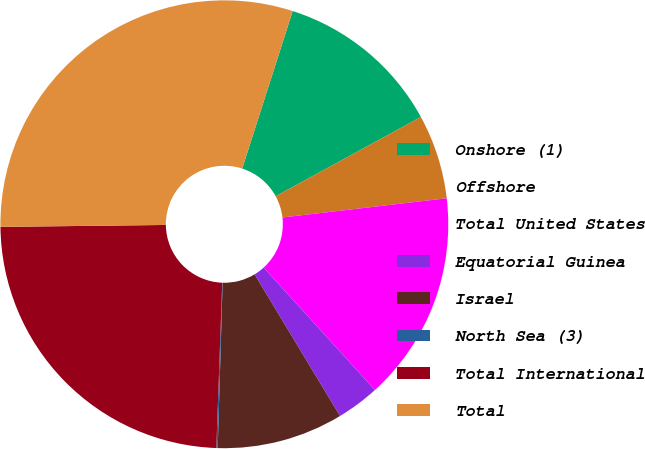Convert chart to OTSL. <chart><loc_0><loc_0><loc_500><loc_500><pie_chart><fcel>Onshore (1)<fcel>Offshore<fcel>Total United States<fcel>Equatorial Guinea<fcel>Israel<fcel>North Sea (3)<fcel>Total International<fcel>Total<nl><fcel>12.11%<fcel>6.1%<fcel>15.11%<fcel>3.1%<fcel>9.11%<fcel>0.1%<fcel>24.24%<fcel>30.12%<nl></chart> 